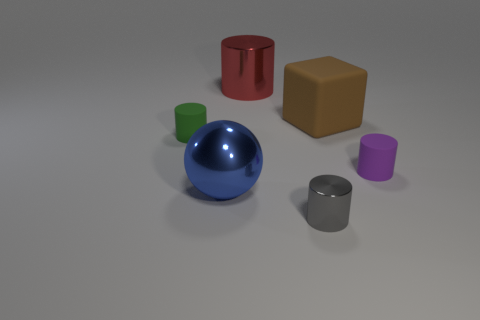What is the size of the thing that is both to the left of the big red cylinder and behind the big blue shiny object?
Your response must be concise. Small. Are there more tiny green rubber cylinders that are on the left side of the cube than large brown blocks in front of the tiny green rubber cylinder?
Keep it short and to the point. Yes. What is the color of the tiny shiny cylinder?
Make the answer very short. Gray. What is the color of the small cylinder that is both to the right of the blue ball and behind the tiny gray metallic thing?
Your answer should be compact. Purple. There is a rubber cylinder that is to the right of the small matte object on the left side of the matte object that is on the right side of the brown rubber object; what color is it?
Give a very brief answer. Purple. What is the color of the metallic cylinder that is the same size as the rubber block?
Make the answer very short. Red. What shape is the tiny matte object that is on the right side of the large metallic object that is in front of the metal thing that is behind the tiny purple cylinder?
Your answer should be compact. Cylinder. How many things are either large balls or tiny matte cylinders left of the rubber block?
Offer a very short reply. 2. Is the size of the brown rubber object that is in front of the red metallic cylinder the same as the red thing?
Keep it short and to the point. Yes. There is a tiny cylinder that is in front of the purple rubber cylinder; what material is it?
Your answer should be compact. Metal. 